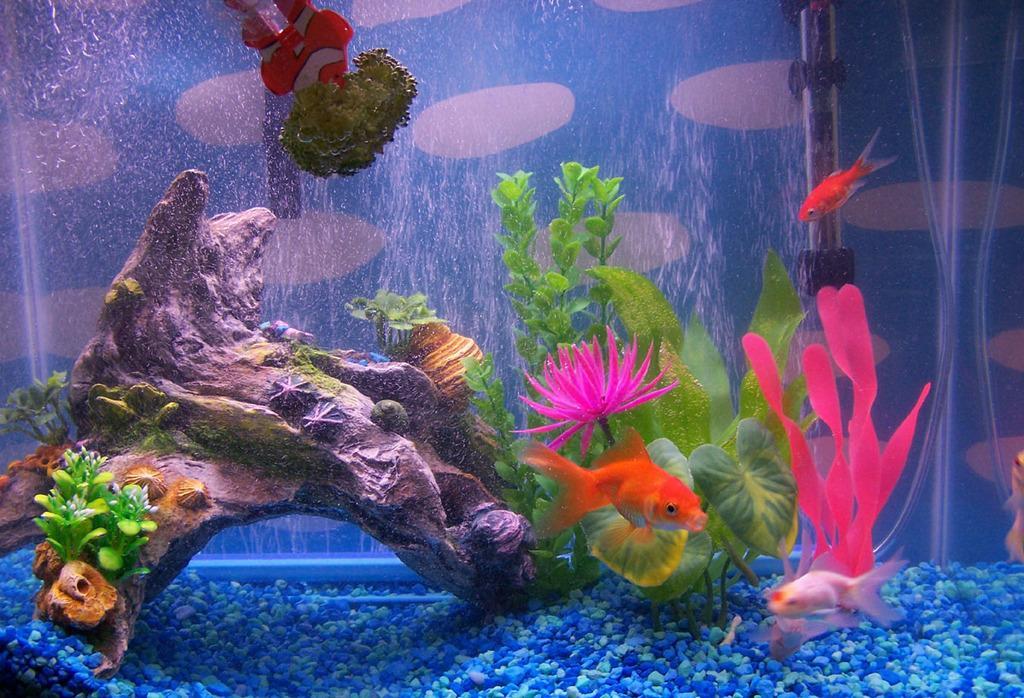Could you give a brief overview of what you see in this image? In this image, we can see inside view of the aquarium. Here we can see some showpieces, water, artificial plants and flowers, dishes. At the bottom, we can see colorful stones. Background we can see blue and white color. He we can see a rod. 